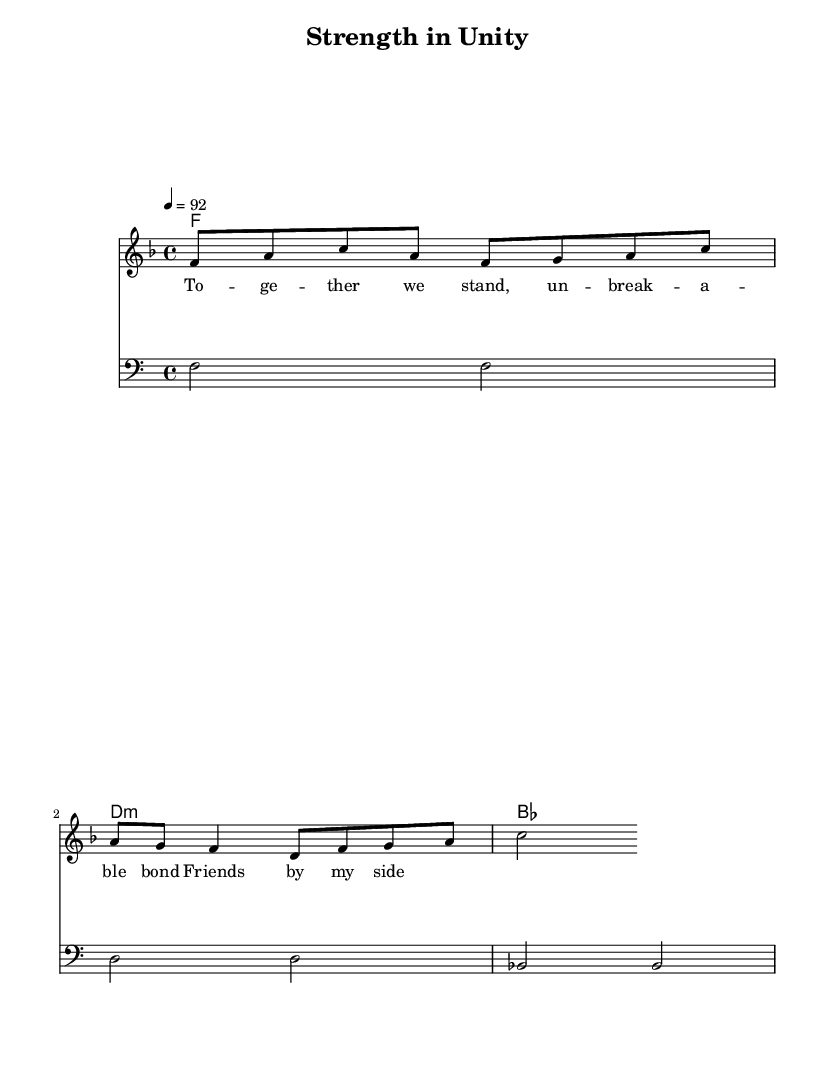What is the key signature of this music? The key signature is F major, which has one flat (B flat).
Answer: F major What is the time signature of this music? The time signature is 4/4, meaning there are four beats in a measure and a quarter note receives one beat.
Answer: 4/4 What is the tempo marking indicated in the score? The tempo marking indicates that the piece should be played at a speed of 92 beats per minute, which is a moderate pace for hip-hop music.
Answer: 92 How many measures are in the melody section? The melody section consists of 4 measures, each containing a different number of notes but fitting within the 4/4 time signature.
Answer: 4 measures What is the first chord of the piece? The first chord shown in the harmonies is F major, indicated by the root note F in the chord mode.
Answer: F What lyrical theme is represented in the verse of this song? The lyrics express themes of unity and friendship, signifying the strength found in bonds between friends, which is a common theme in uplifting rap songs.
Answer: Unity and friendship How does the bassline relate to the melody? The bassline supports the melody by playing root notes of the corresponding chords, creating a harmonic foundation that complements the melody's rhythm and structure.
Answer: Supports harmony 